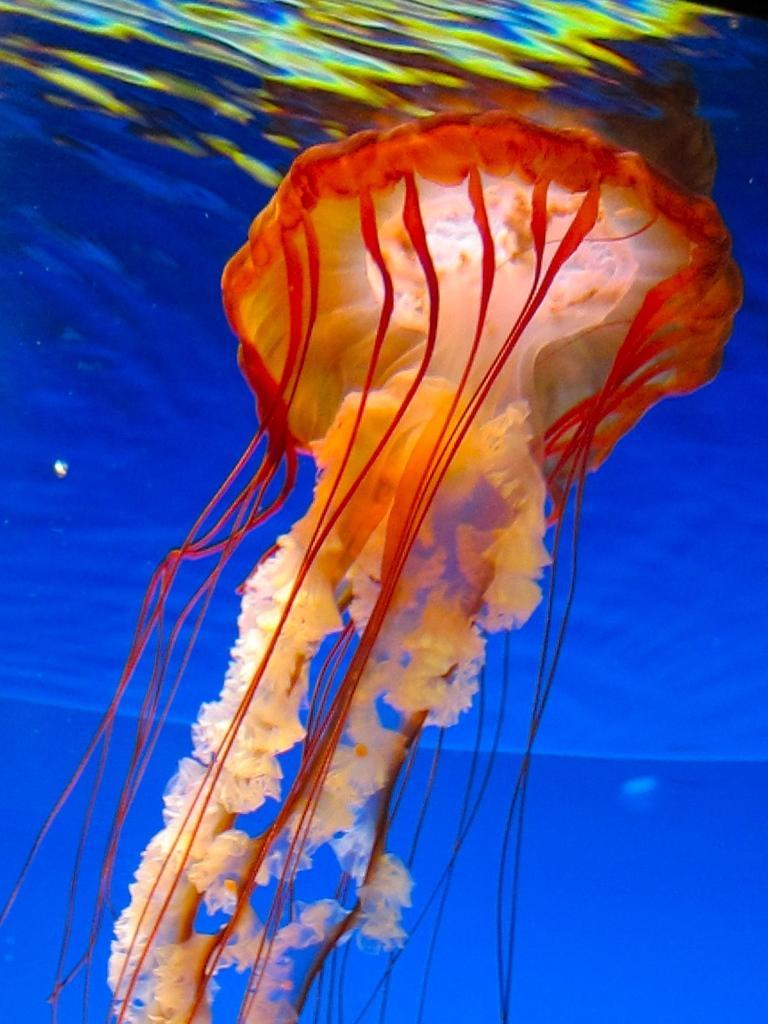In one or two sentences, can you explain what this image depicts? In this image, we can see a jellyfish in the water. 